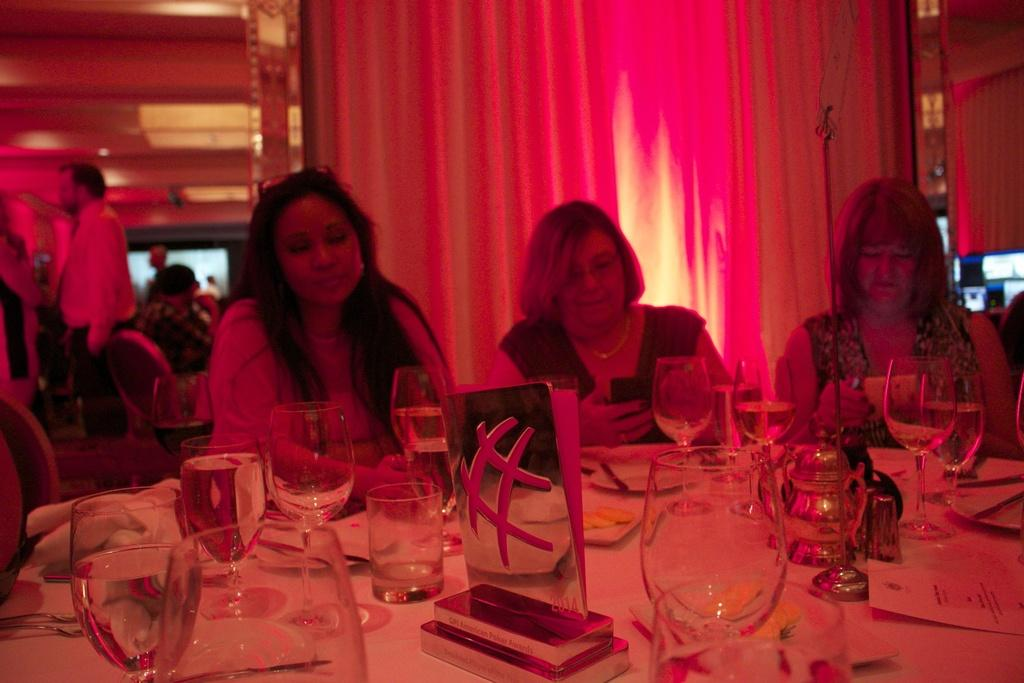How many women are present in the image? There are three women in the image. What are the women doing in the image? The women are sitting in front of a table. What objects can be seen on the table? There are glasses on the table. Can you describe the background of the image? There is a man standing in the background, a curtain, and the ceiling is visible. Where is the man located in the image? The man is in the left corner of the image. What type of scale is visible in the image? There is no scale present in the image. Can you describe the tank in the image? There is no tank present in the image. 